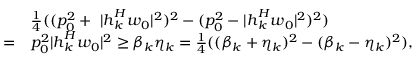<formula> <loc_0><loc_0><loc_500><loc_500>\begin{array} { r l } & { \frac { 1 } { 4 } ( ( p _ { 0 } ^ { 2 } + \ | \boldsymbol h _ { k } ^ { H } \boldsymbol w _ { 0 } | ^ { 2 } ) ^ { 2 } - ( p _ { 0 } ^ { 2 } - | \boldsymbol h _ { k } ^ { H } \boldsymbol w _ { 0 } | ^ { 2 } ) ^ { 2 } ) } \\ { = } & { p _ { 0 } ^ { 2 } | \boldsymbol h _ { k } ^ { H } \boldsymbol w _ { 0 } | ^ { 2 } \geq \beta _ { k } \eta _ { k } = \frac { 1 } { 4 } ( ( \beta _ { k } + \eta _ { k } ) ^ { 2 } - ( \beta _ { k } - \eta _ { k } ) ^ { 2 } ) , } \end{array}</formula> 